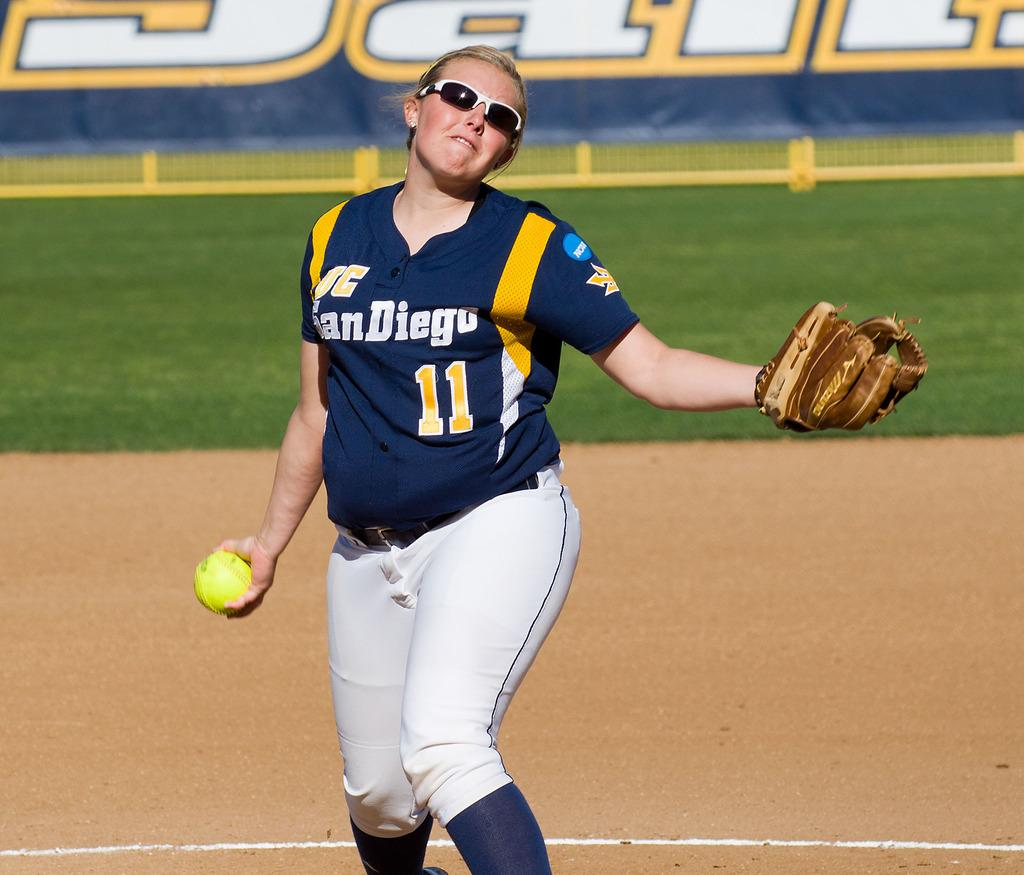<image>
Share a concise interpretation of the image provided. Baseball player wearing a jersey that says San diego. 